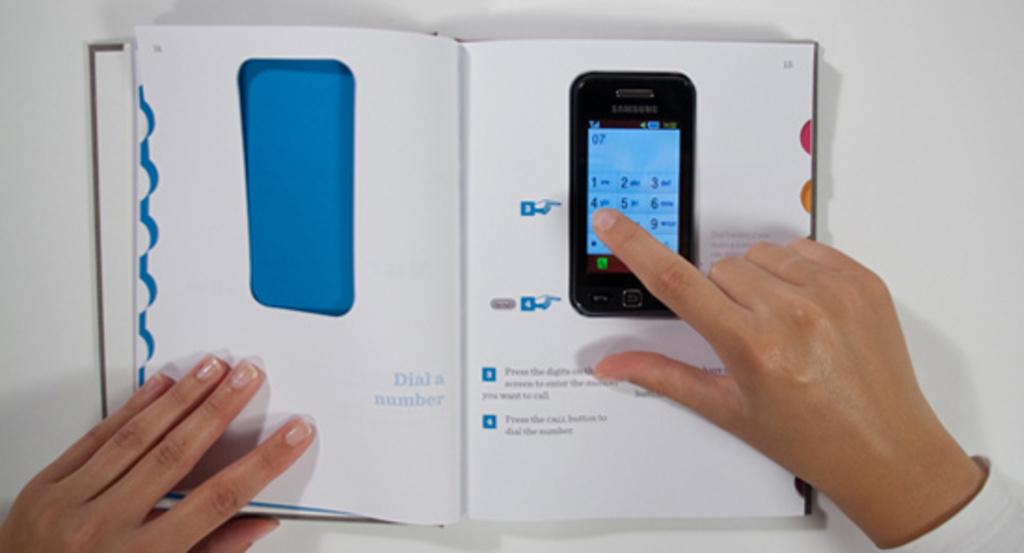<image>
Provide a brief description of the given image. An instruction manual is open to a page titled "dial a number." 